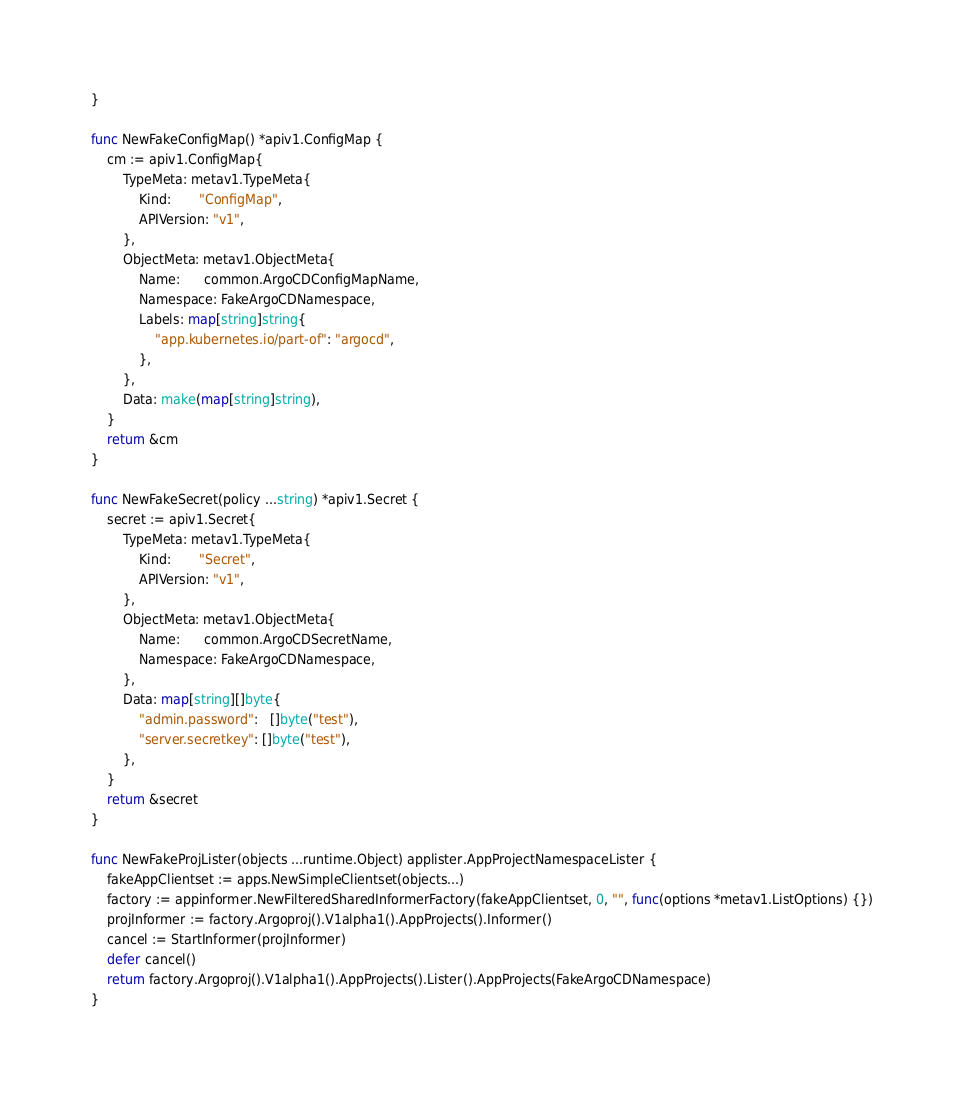<code> <loc_0><loc_0><loc_500><loc_500><_Go_>}

func NewFakeConfigMap() *apiv1.ConfigMap {
	cm := apiv1.ConfigMap{
		TypeMeta: metav1.TypeMeta{
			Kind:       "ConfigMap",
			APIVersion: "v1",
		},
		ObjectMeta: metav1.ObjectMeta{
			Name:      common.ArgoCDConfigMapName,
			Namespace: FakeArgoCDNamespace,
			Labels: map[string]string{
				"app.kubernetes.io/part-of": "argocd",
			},
		},
		Data: make(map[string]string),
	}
	return &cm
}

func NewFakeSecret(policy ...string) *apiv1.Secret {
	secret := apiv1.Secret{
		TypeMeta: metav1.TypeMeta{
			Kind:       "Secret",
			APIVersion: "v1",
		},
		ObjectMeta: metav1.ObjectMeta{
			Name:      common.ArgoCDSecretName,
			Namespace: FakeArgoCDNamespace,
		},
		Data: map[string][]byte{
			"admin.password":   []byte("test"),
			"server.secretkey": []byte("test"),
		},
	}
	return &secret
}

func NewFakeProjLister(objects ...runtime.Object) applister.AppProjectNamespaceLister {
	fakeAppClientset := apps.NewSimpleClientset(objects...)
	factory := appinformer.NewFilteredSharedInformerFactory(fakeAppClientset, 0, "", func(options *metav1.ListOptions) {})
	projInformer := factory.Argoproj().V1alpha1().AppProjects().Informer()
	cancel := StartInformer(projInformer)
	defer cancel()
	return factory.Argoproj().V1alpha1().AppProjects().Lister().AppProjects(FakeArgoCDNamespace)
}
</code> 